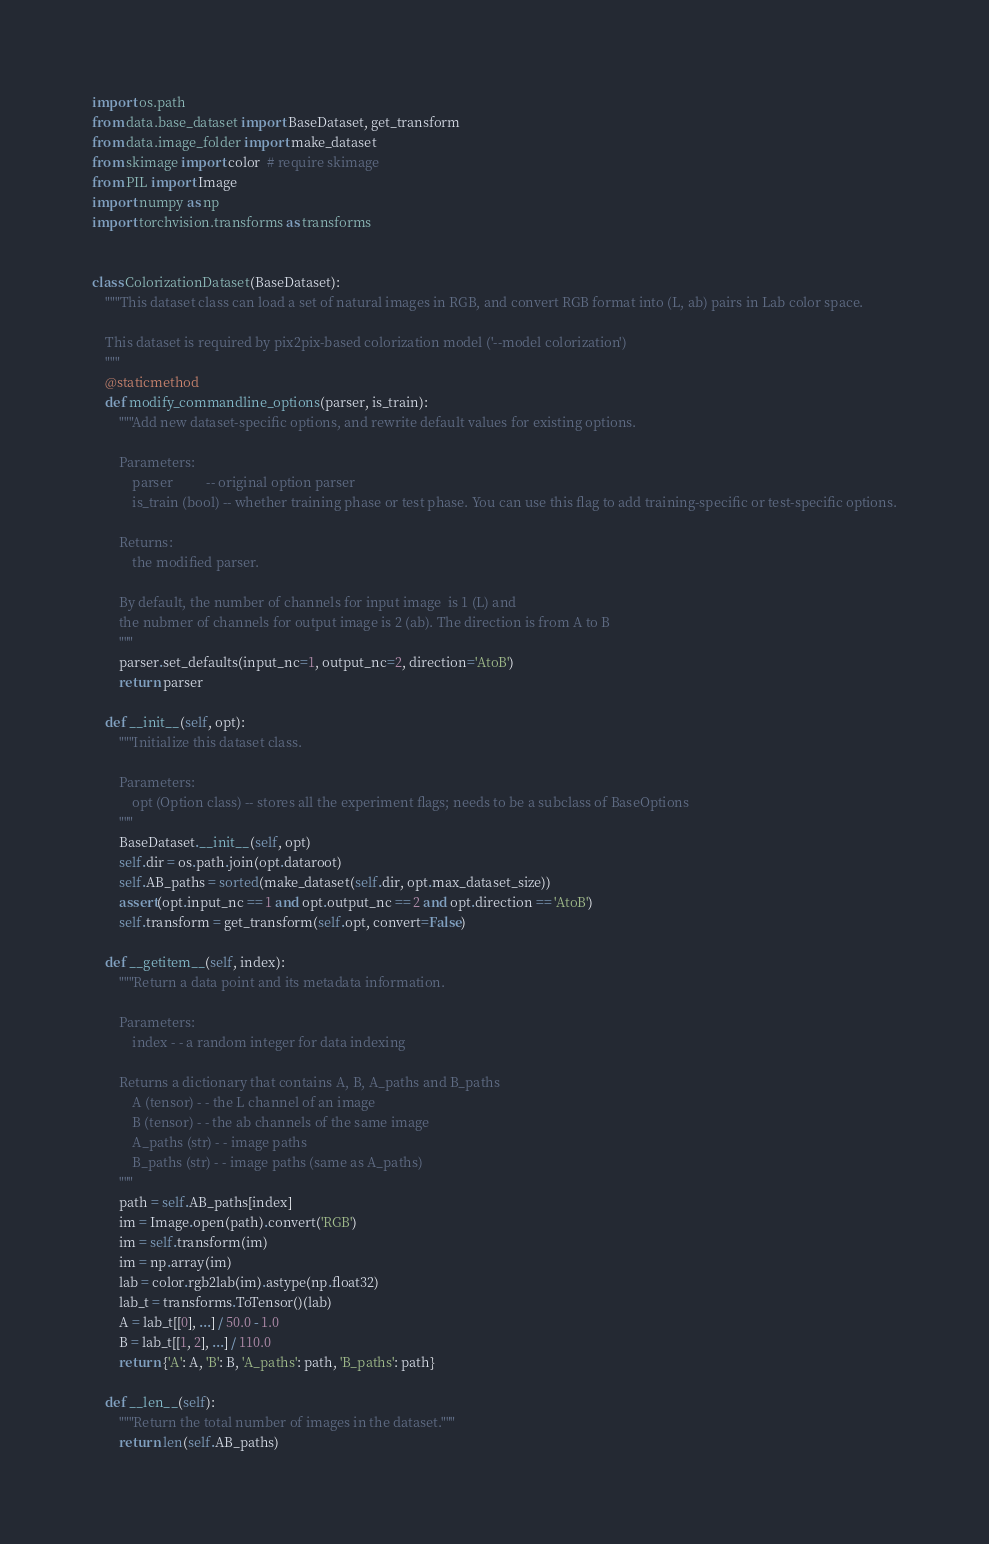Convert code to text. <code><loc_0><loc_0><loc_500><loc_500><_Python_>import os.path
from data.base_dataset import BaseDataset, get_transform
from data.image_folder import make_dataset
from skimage import color  # require skimage
from PIL import Image
import numpy as np
import torchvision.transforms as transforms


class ColorizationDataset(BaseDataset):
    """This dataset class can load a set of natural images in RGB, and convert RGB format into (L, ab) pairs in Lab color space.

    This dataset is required by pix2pix-based colorization model ('--model colorization')
    """
    @staticmethod
    def modify_commandline_options(parser, is_train):
        """Add new dataset-specific options, and rewrite default values for existing options.

        Parameters:
            parser          -- original option parser
            is_train (bool) -- whether training phase or test phase. You can use this flag to add training-specific or test-specific options.

        Returns:
            the modified parser.

        By default, the number of channels for input image  is 1 (L) and
        the nubmer of channels for output image is 2 (ab). The direction is from A to B
        """
        parser.set_defaults(input_nc=1, output_nc=2, direction='AtoB')
        return parser

    def __init__(self, opt):
        """Initialize this dataset class.

        Parameters:
            opt (Option class) -- stores all the experiment flags; needs to be a subclass of BaseOptions
        """
        BaseDataset.__init__(self, opt)
        self.dir = os.path.join(opt.dataroot)
        self.AB_paths = sorted(make_dataset(self.dir, opt.max_dataset_size))
        assert(opt.input_nc == 1 and opt.output_nc == 2 and opt.direction == 'AtoB')
        self.transform = get_transform(self.opt, convert=False)

    def __getitem__(self, index):
        """Return a data point and its metadata information.

        Parameters:
            index - - a random integer for data indexing

        Returns a dictionary that contains A, B, A_paths and B_paths
            A (tensor) - - the L channel of an image
            B (tensor) - - the ab channels of the same image
            A_paths (str) - - image paths
            B_paths (str) - - image paths (same as A_paths)
        """
        path = self.AB_paths[index]
        im = Image.open(path).convert('RGB')
        im = self.transform(im)
        im = np.array(im)
        lab = color.rgb2lab(im).astype(np.float32)
        lab_t = transforms.ToTensor()(lab)
        A = lab_t[[0], ...] / 50.0 - 1.0
        B = lab_t[[1, 2], ...] / 110.0
        return {'A': A, 'B': B, 'A_paths': path, 'B_paths': path}

    def __len__(self):
        """Return the total number of images in the dataset."""
        return len(self.AB_paths)
</code> 